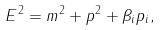<formula> <loc_0><loc_0><loc_500><loc_500>E ^ { 2 } = m ^ { 2 } + p ^ { 2 } + \beta _ { i } p _ { i } ,</formula> 